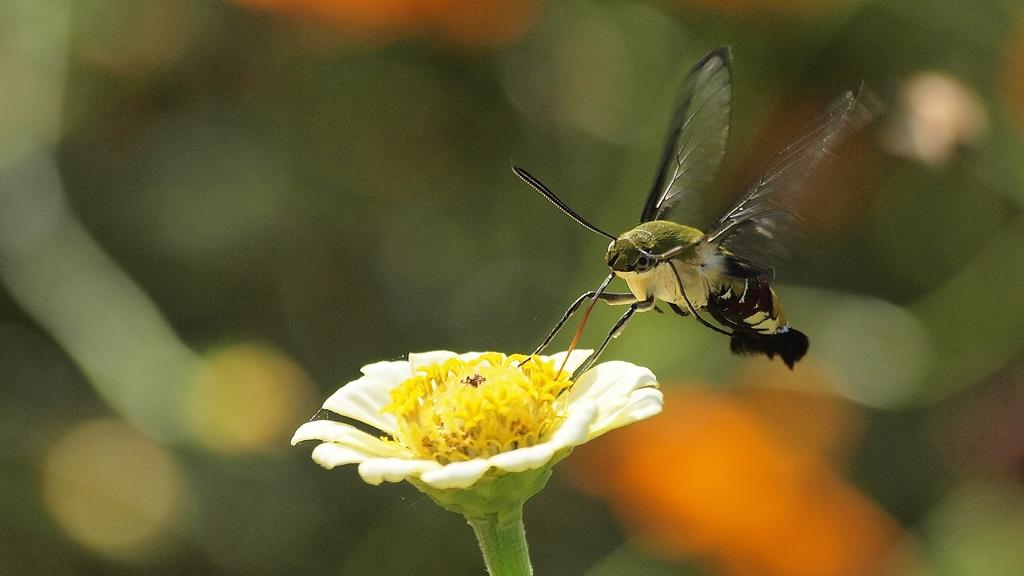What is the main subject of the image? There is a butterfly in the image. Where is the butterfly located in the image? The butterfly is sitting on a white flower. Can you describe the background of the image? The background of the image is blurred. What type of throne is the butterfly sitting on in the image? There is no throne present in the image; the butterfly is sitting on a white flower. 